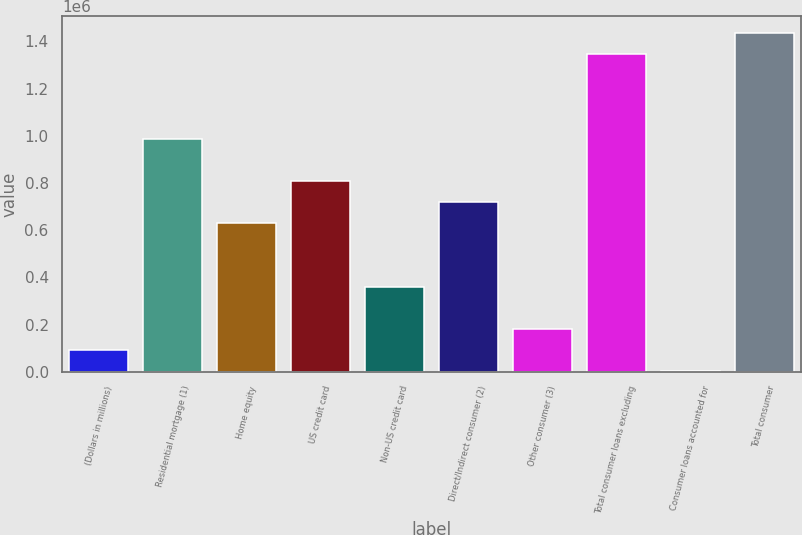<chart> <loc_0><loc_0><loc_500><loc_500><bar_chart><fcel>(Dollars in millions)<fcel>Residential mortgage (1)<fcel>Home equity<fcel>US credit card<fcel>Non-US credit card<fcel>Direct/Indirect consumer (2)<fcel>Other consumer (3)<fcel>Total consumer loans excluding<fcel>Consumer loans accounted for<fcel>Total consumer<nl><fcel>91382.2<fcel>986494<fcel>628449<fcel>807472<fcel>359916<fcel>717961<fcel>180893<fcel>1.34454e+06<fcel>1871<fcel>1.43405e+06<nl></chart> 